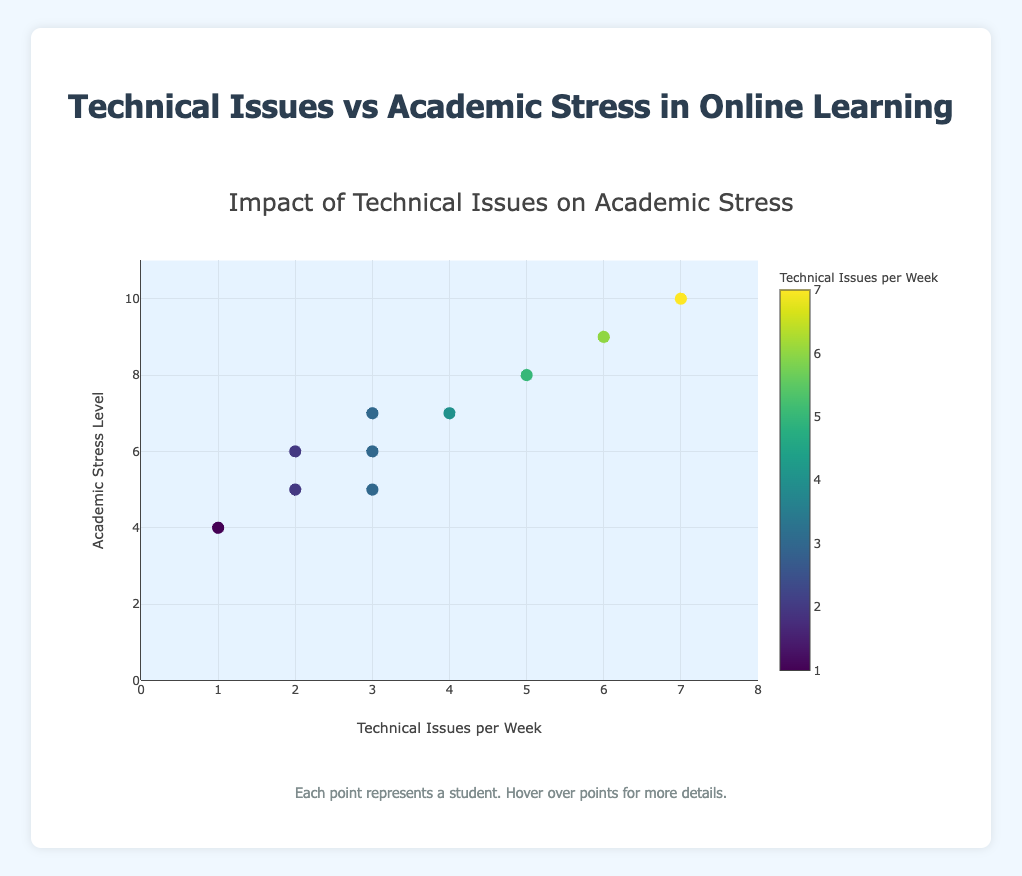What does the title of the scatter plot indicate? The title of the scatter plot is "Impact of Technical Issues on Academic Stress," which indicates that the plot shows how the frequency of technical issues faced by students influences their academic stress levels.
Answer: Impact of Technical Issues on Academic Stress What are the x-axis and y-axis labels in the scatter plot? The x-axis is labeled "Technical Issues per Week," representing the number of technical issues faced by students each week. The y-axis is labeled "Academic Stress Level," representing the level of academic stress among students.
Answer: Technical Issues per Week and Academic Stress Level How many students reported 3 technical issues per week? From the plot, there are markers at 3 technical issues per week for students S001, S009 (both with academic stress level 5), and S007 (with academic stress level 6).
Answer: 3 students Which platform has the student with the highest academic stress level? The plot indicates that the student S008 using "Zoom" has the highest recorded academic stress level of 10.
Answer: Zoom What is the general trend observed in the scatter plot between technical issues and academic stress levels? There is a clear trend in the plot showing that as the number of technical issues per week increases, the academic stress level also tends to increase.
Answer: Positive correlation Which student is an outlier in terms of the number of technical issues faced per week? The student S008, who reported 7 technical issues per week, is an outlier because this is the highest number of issues compared to the other students.
Answer: S008 How many students reported an academic stress level of 6? The plot indicates that students S007 and S010 both have an academic stress level of 6.
Answer: 2 students Which platform seems to have more students facing higher academic stress levels? The plot shows that "Zoom" with students S001, S004, and S008, all have relatively high academic stress levels (7, 7, and 10, respectively).
Answer: Zoom What's the average number of technical issues faced per week among all students? To find the average, sum up the technical issues per week for all students (3+5+2+4+1+6+3+7+3+2 = 36) and divide by the number of students (10). The average is 36/10 = 3.6.
Answer: 3.6 Are there any students who report no technical issues per week? The plot only shows points starting from "1" technical issue per week and higher, indicating there are no students reporting zero technical issues within this data set.
Answer: No 